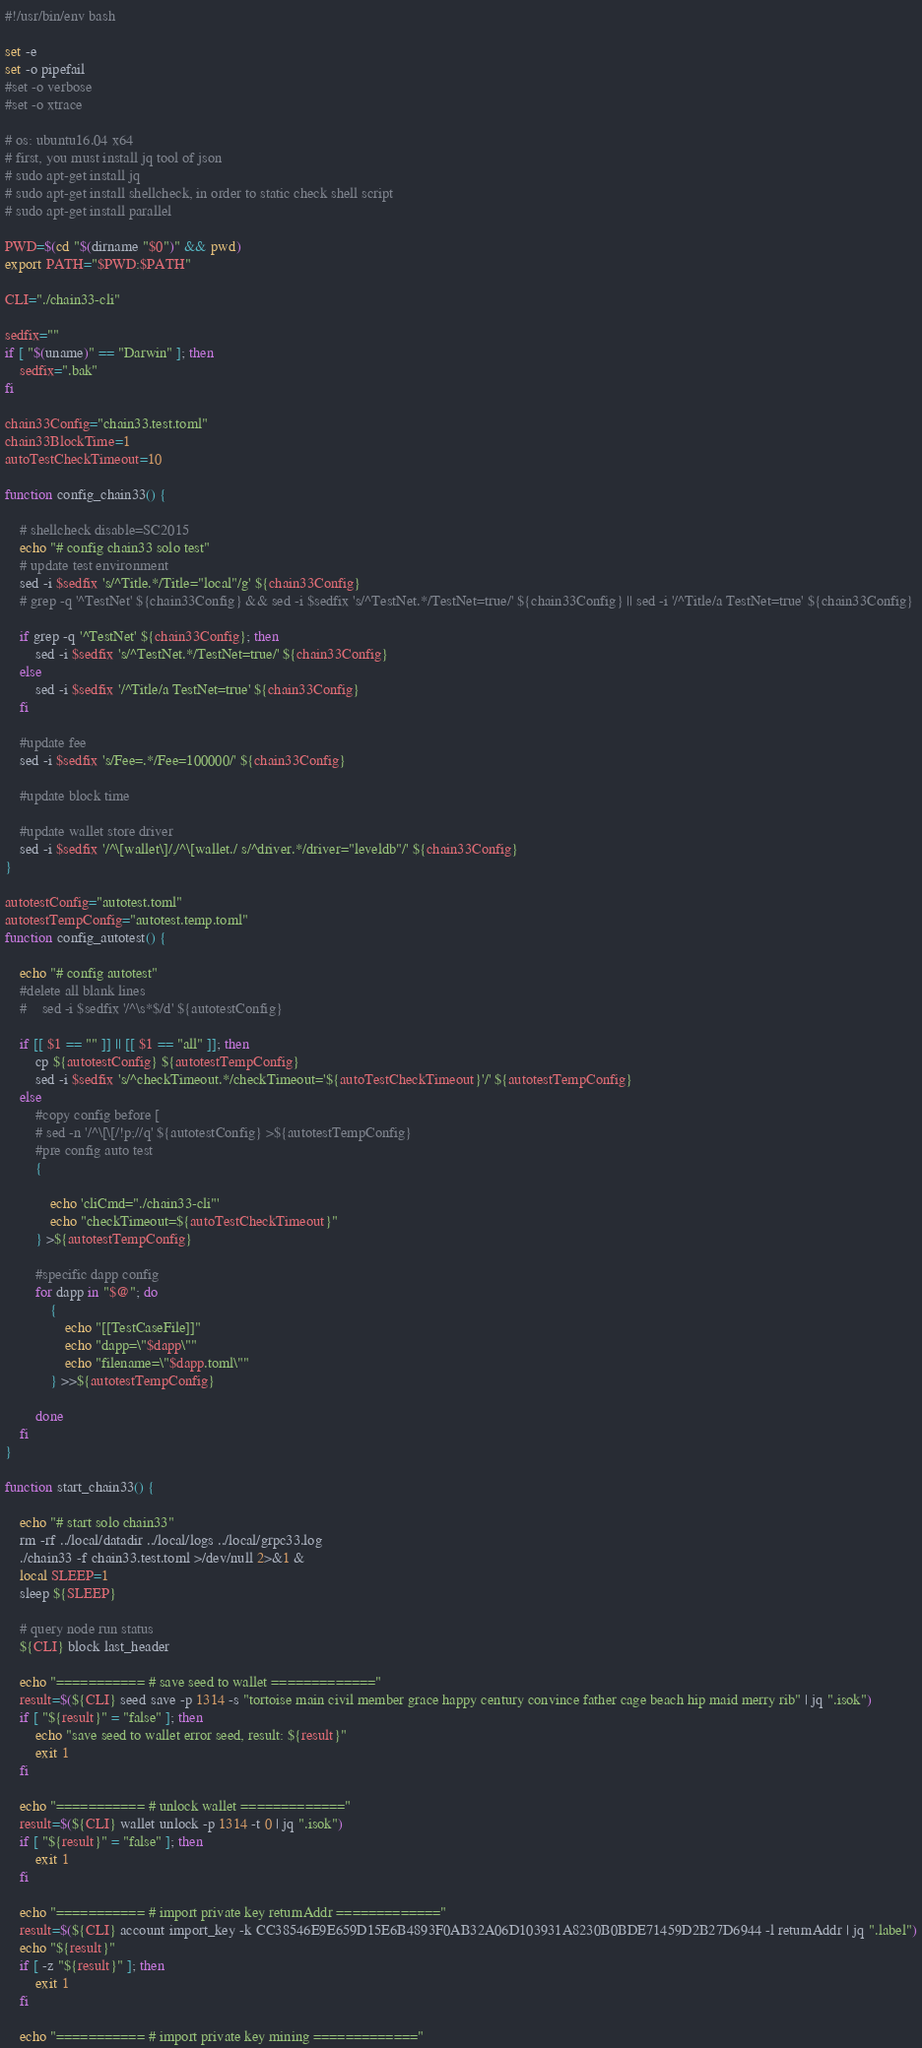<code> <loc_0><loc_0><loc_500><loc_500><_Bash_>#!/usr/bin/env bash

set -e
set -o pipefail
#set -o verbose
#set -o xtrace

# os: ubuntu16.04 x64
# first, you must install jq tool of json
# sudo apt-get install jq
# sudo apt-get install shellcheck, in order to static check shell script
# sudo apt-get install parallel

PWD=$(cd "$(dirname "$0")" && pwd)
export PATH="$PWD:$PATH"

CLI="./chain33-cli"

sedfix=""
if [ "$(uname)" == "Darwin" ]; then
    sedfix=".bak"
fi

chain33Config="chain33.test.toml"
chain33BlockTime=1
autoTestCheckTimeout=10

function config_chain33() {

    # shellcheck disable=SC2015
    echo "# config chain33 solo test"
    # update test environment
    sed -i $sedfix 's/^Title.*/Title="local"/g' ${chain33Config}
    # grep -q '^TestNet' ${chain33Config} && sed -i $sedfix 's/^TestNet.*/TestNet=true/' ${chain33Config} || sed -i '/^Title/a TestNet=true' ${chain33Config}

    if grep -q '^TestNet' ${chain33Config}; then
        sed -i $sedfix 's/^TestNet.*/TestNet=true/' ${chain33Config}
    else
        sed -i $sedfix '/^Title/a TestNet=true' ${chain33Config}
    fi

    #update fee
    sed -i $sedfix 's/Fee=.*/Fee=100000/' ${chain33Config}

    #update block time

    #update wallet store driver
    sed -i $sedfix '/^\[wallet\]/,/^\[wallet./ s/^driver.*/driver="leveldb"/' ${chain33Config}
}

autotestConfig="autotest.toml"
autotestTempConfig="autotest.temp.toml"
function config_autotest() {

    echo "# config autotest"
    #delete all blank lines
    #    sed -i $sedfix '/^\s*$/d' ${autotestConfig}

    if [[ $1 == "" ]] || [[ $1 == "all" ]]; then
        cp ${autotestConfig} ${autotestTempConfig}
        sed -i $sedfix 's/^checkTimeout.*/checkTimeout='${autoTestCheckTimeout}'/' ${autotestTempConfig}
    else
        #copy config before [
        # sed -n '/^\[\[/!p;//q' ${autotestConfig} >${autotestTempConfig}
        #pre config auto test
        {

            echo 'cliCmd="./chain33-cli"'
            echo "checkTimeout=${autoTestCheckTimeout}"
        } >${autotestTempConfig}

        #specific dapp config
        for dapp in "$@"; do
            {
                echo "[[TestCaseFile]]"
                echo "dapp=\"$dapp\""
                echo "filename=\"$dapp.toml\""
            } >>${autotestTempConfig}

        done
    fi
}

function start_chain33() {

    echo "# start solo chain33"
    rm -rf ../local/datadir ../local/logs ../local/grpc33.log
    ./chain33 -f chain33.test.toml >/dev/null 2>&1 &
    local SLEEP=1
    sleep ${SLEEP}

    # query node run status
    ${CLI} block last_header

    echo "=========== # save seed to wallet ============="
    result=$(${CLI} seed save -p 1314 -s "tortoise main civil member grace happy century convince father cage beach hip maid merry rib" | jq ".isok")
    if [ "${result}" = "false" ]; then
        echo "save seed to wallet error seed, result: ${result}"
        exit 1
    fi

    echo "=========== # unlock wallet ============="
    result=$(${CLI} wallet unlock -p 1314 -t 0 | jq ".isok")
    if [ "${result}" = "false" ]; then
        exit 1
    fi

    echo "=========== # import private key returnAddr ============="
    result=$(${CLI} account import_key -k CC38546E9E659D15E6B4893F0AB32A06D103931A8230B0BDE71459D2B27D6944 -l returnAddr | jq ".label")
    echo "${result}"
    if [ -z "${result}" ]; then
        exit 1
    fi

    echo "=========== # import private key mining ============="</code> 